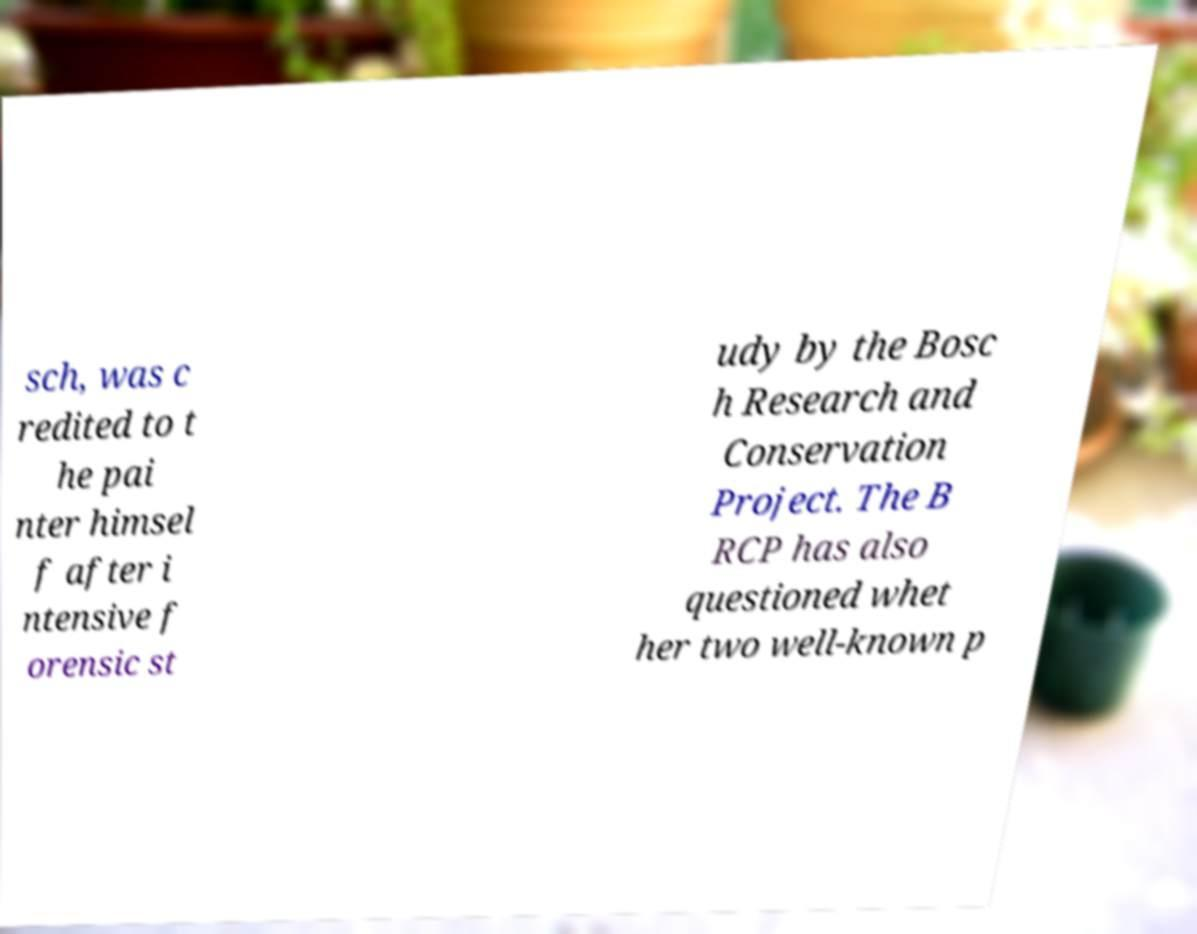For documentation purposes, I need the text within this image transcribed. Could you provide that? sch, was c redited to t he pai nter himsel f after i ntensive f orensic st udy by the Bosc h Research and Conservation Project. The B RCP has also questioned whet her two well-known p 